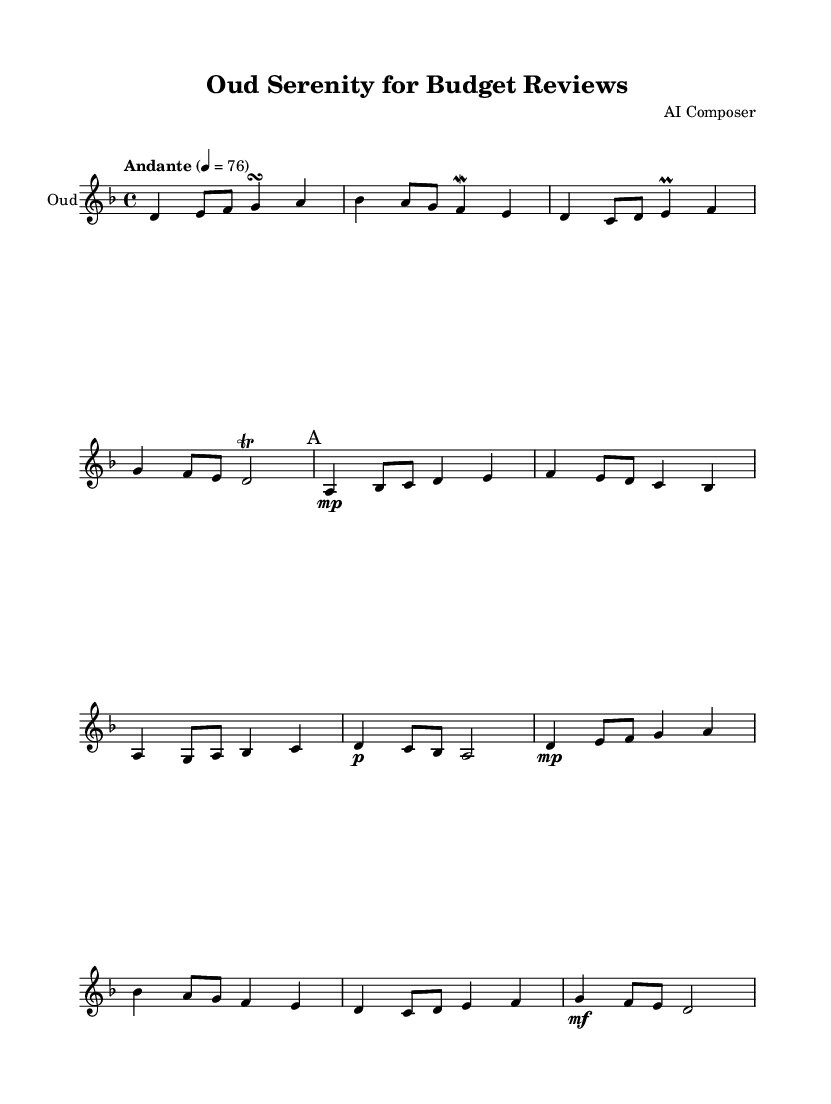What is the key signature of this music? The key signature is indicated on the staff and shows two flats (B♭ and E♭), which means the piece is in D minor or F major. However, since the context suggests a modal quality, it confirms that the key is D minor.
Answer: D minor What is the time signature of this music? The time signature is located at the beginning of the score, where it is defined as 4/4, indicating a four beats per measure structure.
Answer: 4/4 What is the tempo marking of this piece? The tempo marking is specified at the start with "Andante," indicating a moderate pace. It's shown as 4 = 76, meaning there are 76 beats per minute.
Answer: Andante How many measures are in the main theme A? The main theme A consists of four measures, identifiable by music lines containing notes between the marking of "A" and the subsequent variation.
Answer: 4 What note value is given to the first note of the main theme A? The first note of the main theme A (A) is written as a quarter note, which typically receives one beat in the 4/4 time signature.
Answer: Quarter note What ornament is used in the introduction section? The introduction features a trill marked above the note D, indicating a rapid alternation between the note and the one above it.
Answer: Trill What melodic structure is employed in the main theme variation? The variation on theme A incorporates a similar melodic contour to the original theme while introducing slight alterations to maintain interest. This is a common practice in Middle Eastern music to create variations.
Answer: Variation 